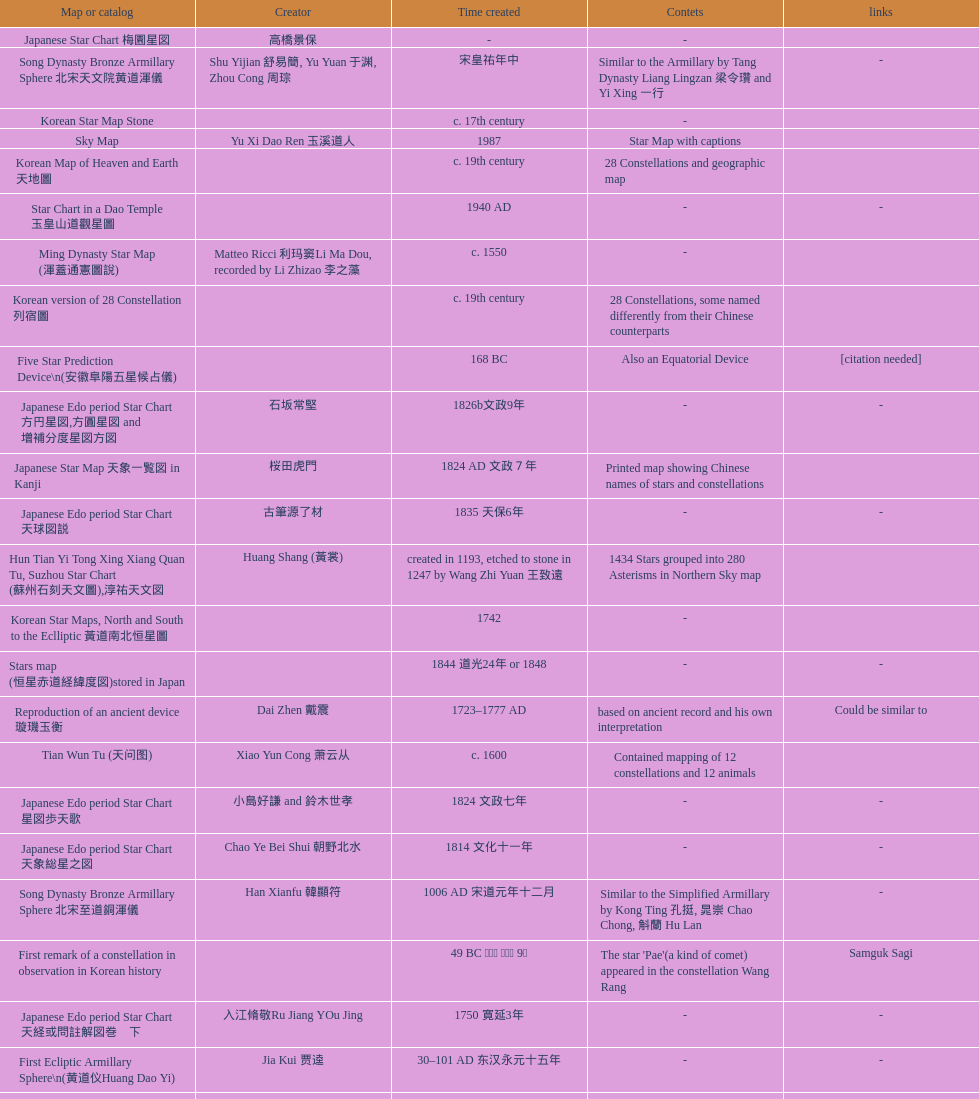Did xu guang ci or su song create the five star charts in 1094 ad? Su Song 蘇頌. 